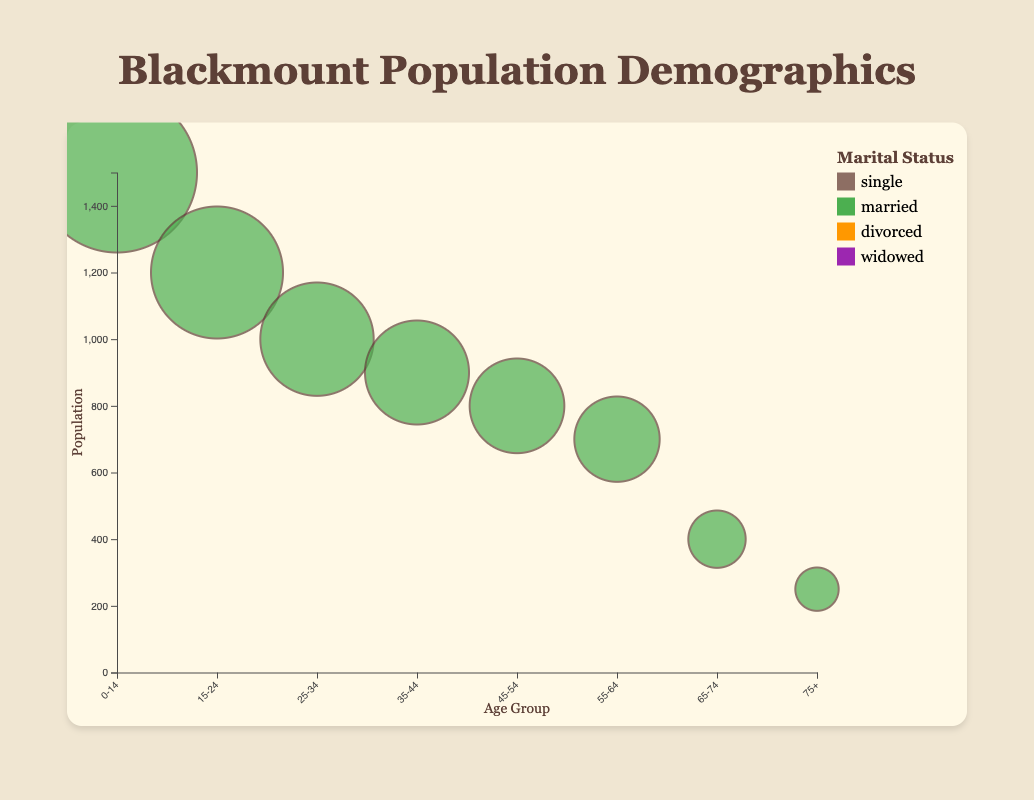What is the population of the 15-24 age group? The figure shows bubbles representing different age groups, and the population is labeled when you hover. From the bubble representing the 15-24 age group, you can see the population is given as 1200.
Answer: 1200 Which age group has the highest population? By looking at the size of the bubbles, you can see the largest one represents the 0-14 age group, which has the highest population. The tooltip for this age group shows a population of 1500.
Answer: 0-14 What is the marital status distribution for the 75+ age group? Hovering over the bubble for the 75+ age group reveals details on marital status: Single: 5, Married: 100, Divorced: 20, Widowed: 125.
Answer: Single: 5, Married: 100, Divorced: 20, Widowed: 125 How do the populations compare between the 55-64 and 65-74 age groups? Comparing the sizes of the bubbles for these age groups shows the 55-64 age group has a population of 700, while the 65-74 age group has a population of 400.
Answer: 55-64: 700, 65-74: 400 Which marital status appears to be the least common across all age groups? Observing the colors and sizes of sections within each bubble, the widowed status seems to be the least common, with only small sections in older age groups.
Answer: Widowed What is the total population of the age groups 25-34 and 35-44 combined? The population for 25-34 is 1000, and for 35-44 it is 900. Adding these gives 1000 + 900 = 1900.
Answer: 1900 Which age group has the highest number of married individuals? By hovering over each bubble and checking the marital status distribution, the 35-44 age group has the highest number of married individuals at 700.
Answer: 35-44 What percentage of the 45-54 age group is divorced? The 45-54 age group's total population is 800, with 100 divorced individuals. The percentage is (100/800) * 100 = 12.5%.
Answer: 12.5% Among individuals aged 0-14, what is the proportion of single individuals? Since all 1500 individuals in the 0-14 age group are single, the proportion is 1500/1500 = 1 or 100%.
Answer: 100% How does the number of divorced individuals compare between the age groups 25-34 and 55-64? The 25-34 age group has 50 divorced individuals, while the 55-64 age group has 100. Comparing these, the 55-64 age group has twice the number of divorced individuals.
Answer: 55-64 is double 25-34 